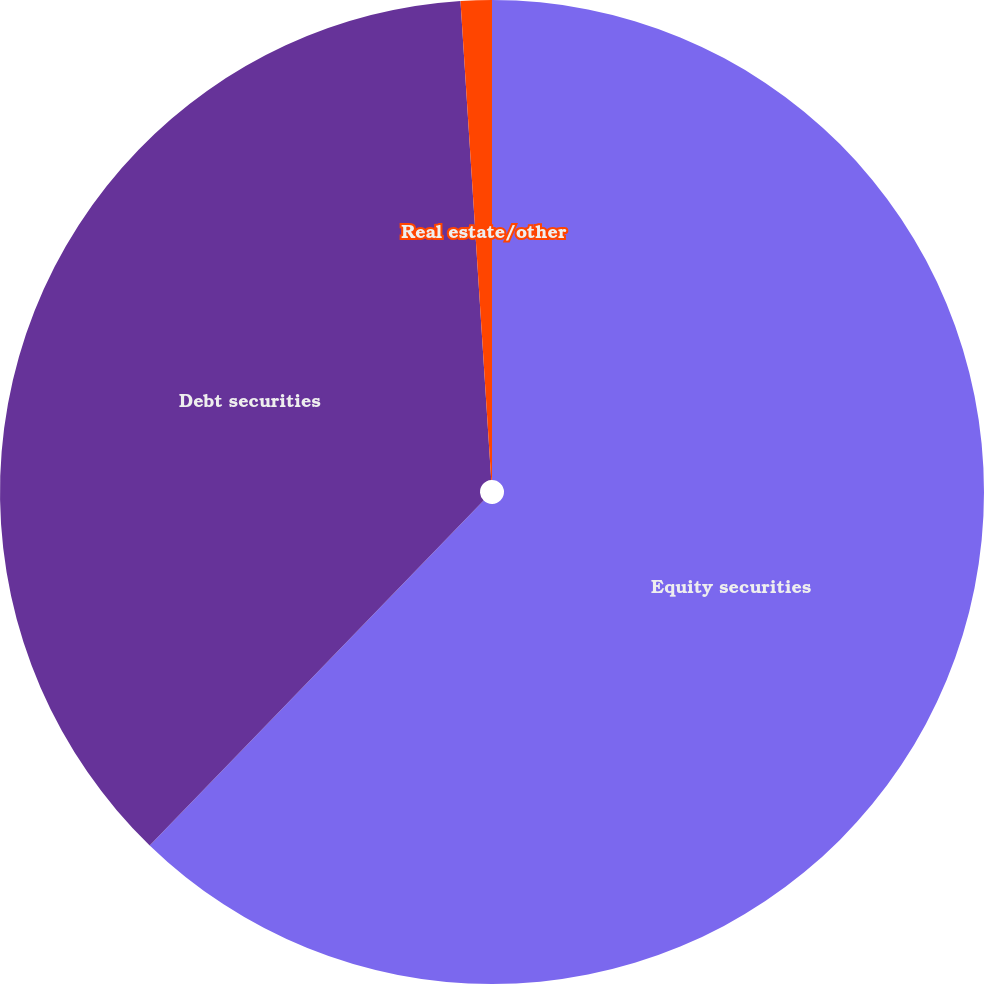Convert chart to OTSL. <chart><loc_0><loc_0><loc_500><loc_500><pie_chart><fcel>Equity securities<fcel>Debt securities<fcel>Real estate/other<nl><fcel>62.24%<fcel>36.73%<fcel>1.02%<nl></chart> 